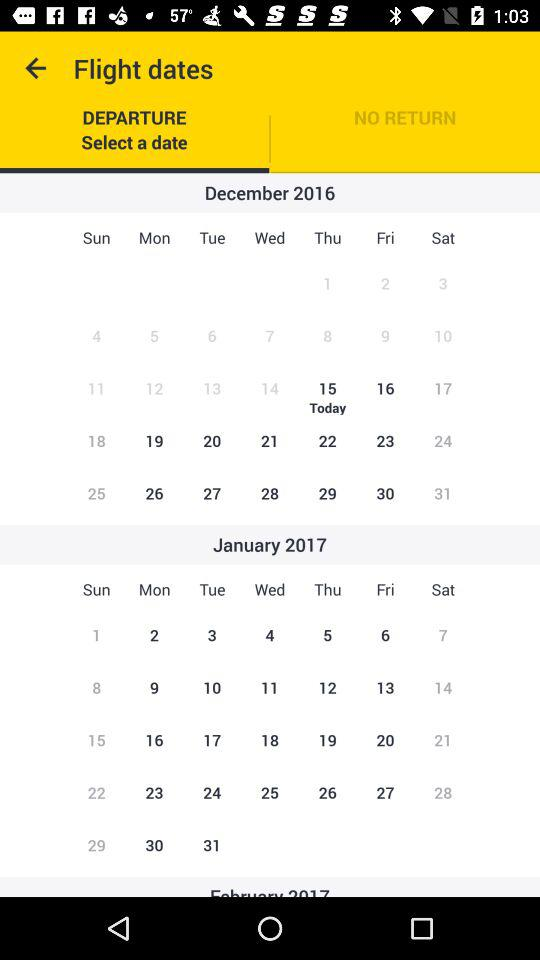What is today's date? Today's date is Thursday, December 15, 2016. 